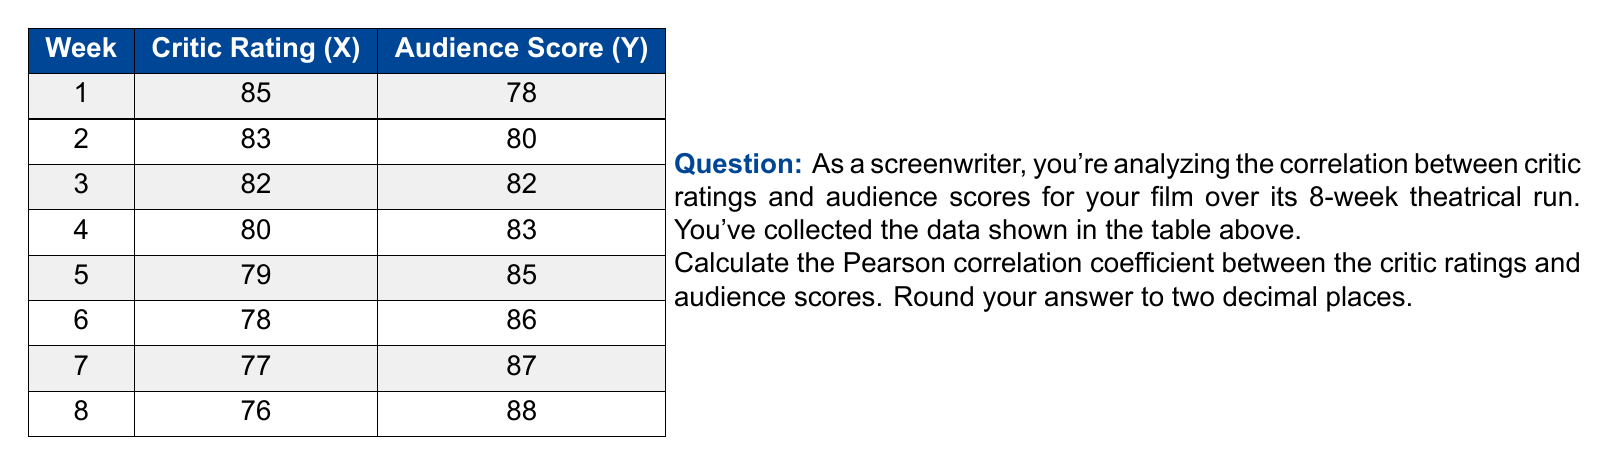Help me with this question. To calculate the Pearson correlation coefficient, we'll use the formula:

$$ r = \frac{\sum_{i=1}^{n} (x_i - \bar{x})(y_i - \bar{y})}{\sqrt{\sum_{i=1}^{n} (x_i - \bar{x})^2 \sum_{i=1}^{n} (y_i - \bar{y})^2}} $$

Where:
$x_i$ and $y_i$ are the individual sample points
$\bar{x}$ and $\bar{y}$ are the sample means

Step 1: Calculate the means
$\bar{x} = \frac{85 + 83 + 82 + 80 + 79 + 78 + 77 + 76}{8} = 80$
$\bar{y} = \frac{78 + 80 + 82 + 83 + 85 + 86 + 87 + 88}{8} = 83.625$

Step 2: Calculate $(x_i - \bar{x})$, $(y_i - \bar{y})$, $(x_i - \bar{x})^2$, $(y_i - \bar{y})^2$, and $(x_i - \bar{x})(y_i - \bar{y})$ for each data point.

Step 3: Sum up the values calculated in Step 2:
$\sum (x_i - \bar{x})(y_i - \bar{y}) = -140.625$
$\sum (x_i - \bar{x})^2 = 70$
$\sum (y_i - \bar{y})^2 = 70.875$

Step 4: Apply the formula:

$$ r = \frac{-140.625}{\sqrt{70 * 70.875}} = -0.9996 $$

Step 5: Round to two decimal places: -1.00
Answer: -1.00 